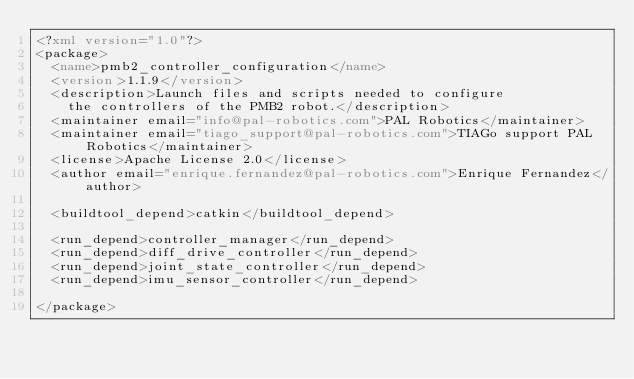Convert code to text. <code><loc_0><loc_0><loc_500><loc_500><_XML_><?xml version="1.0"?>
<package>
  <name>pmb2_controller_configuration</name>
  <version>1.1.9</version>
  <description>Launch files and scripts needed to configure
    the controllers of the PMB2 robot.</description>
  <maintainer email="info@pal-robotics.com">PAL Robotics</maintainer>
  <maintainer email="tiago_support@pal-robotics.com">TIAGo support PAL Robotics</maintainer>
  <license>Apache License 2.0</license>
  <author email="enrique.fernandez@pal-robotics.com">Enrique Fernandez</author>

  <buildtool_depend>catkin</buildtool_depend>

  <run_depend>controller_manager</run_depend>
  <run_depend>diff_drive_controller</run_depend>
  <run_depend>joint_state_controller</run_depend>
  <run_depend>imu_sensor_controller</run_depend>

</package>
</code> 